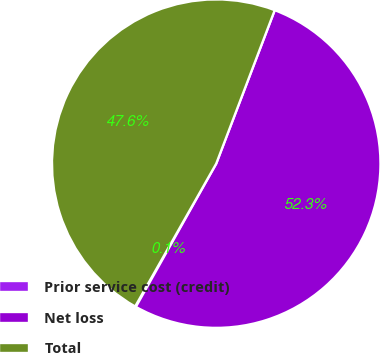Convert chart to OTSL. <chart><loc_0><loc_0><loc_500><loc_500><pie_chart><fcel>Prior service cost (credit)<fcel>Net loss<fcel>Total<nl><fcel>0.08%<fcel>52.34%<fcel>47.58%<nl></chart> 